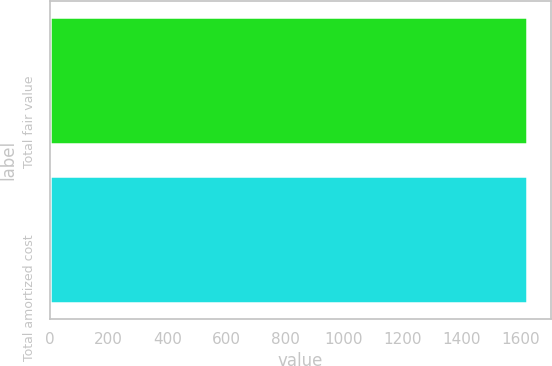Convert chart to OTSL. <chart><loc_0><loc_0><loc_500><loc_500><bar_chart><fcel>Total fair value<fcel>Total amortized cost<nl><fcel>1623<fcel>1621<nl></chart> 